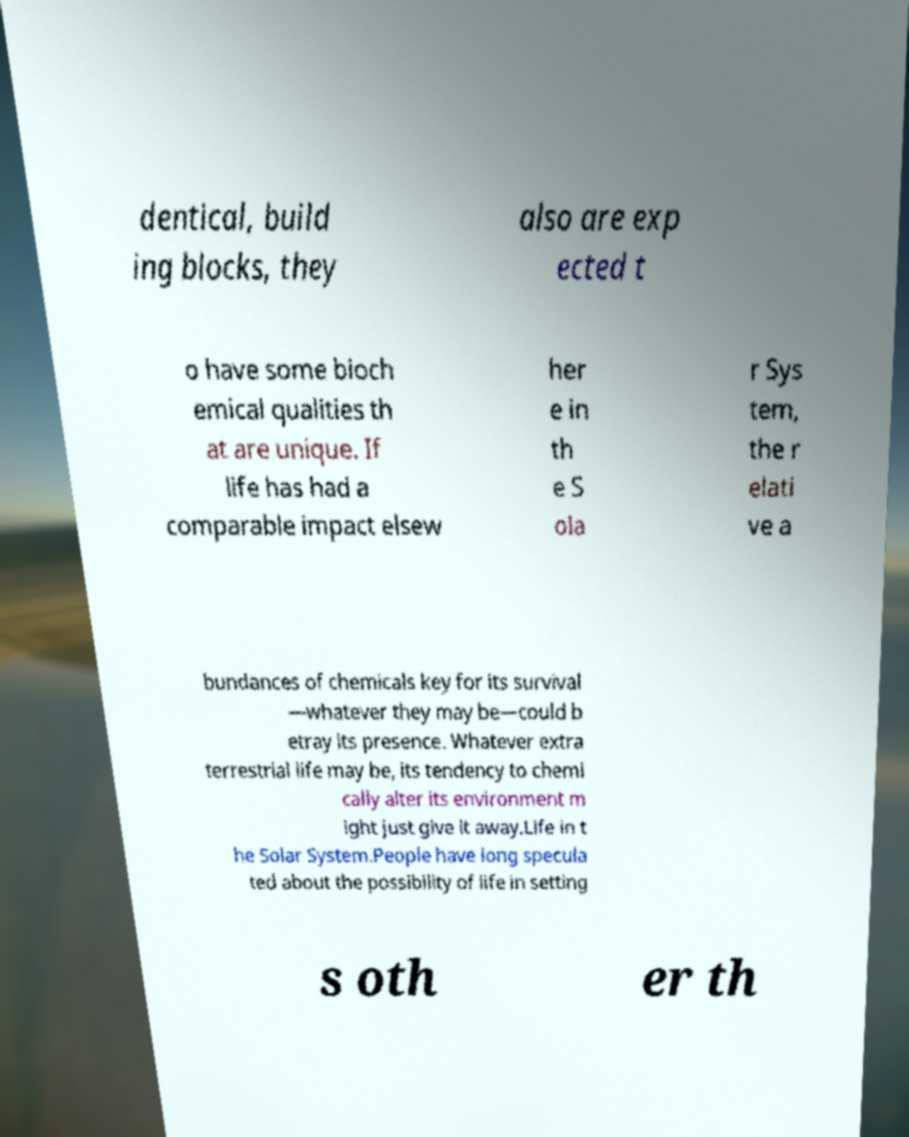Could you assist in decoding the text presented in this image and type it out clearly? dentical, build ing blocks, they also are exp ected t o have some bioch emical qualities th at are unique. If life has had a comparable impact elsew her e in th e S ola r Sys tem, the r elati ve a bundances of chemicals key for its survival —whatever they may be—could b etray its presence. Whatever extra terrestrial life may be, its tendency to chemi cally alter its environment m ight just give it away.Life in t he Solar System.People have long specula ted about the possibility of life in setting s oth er th 